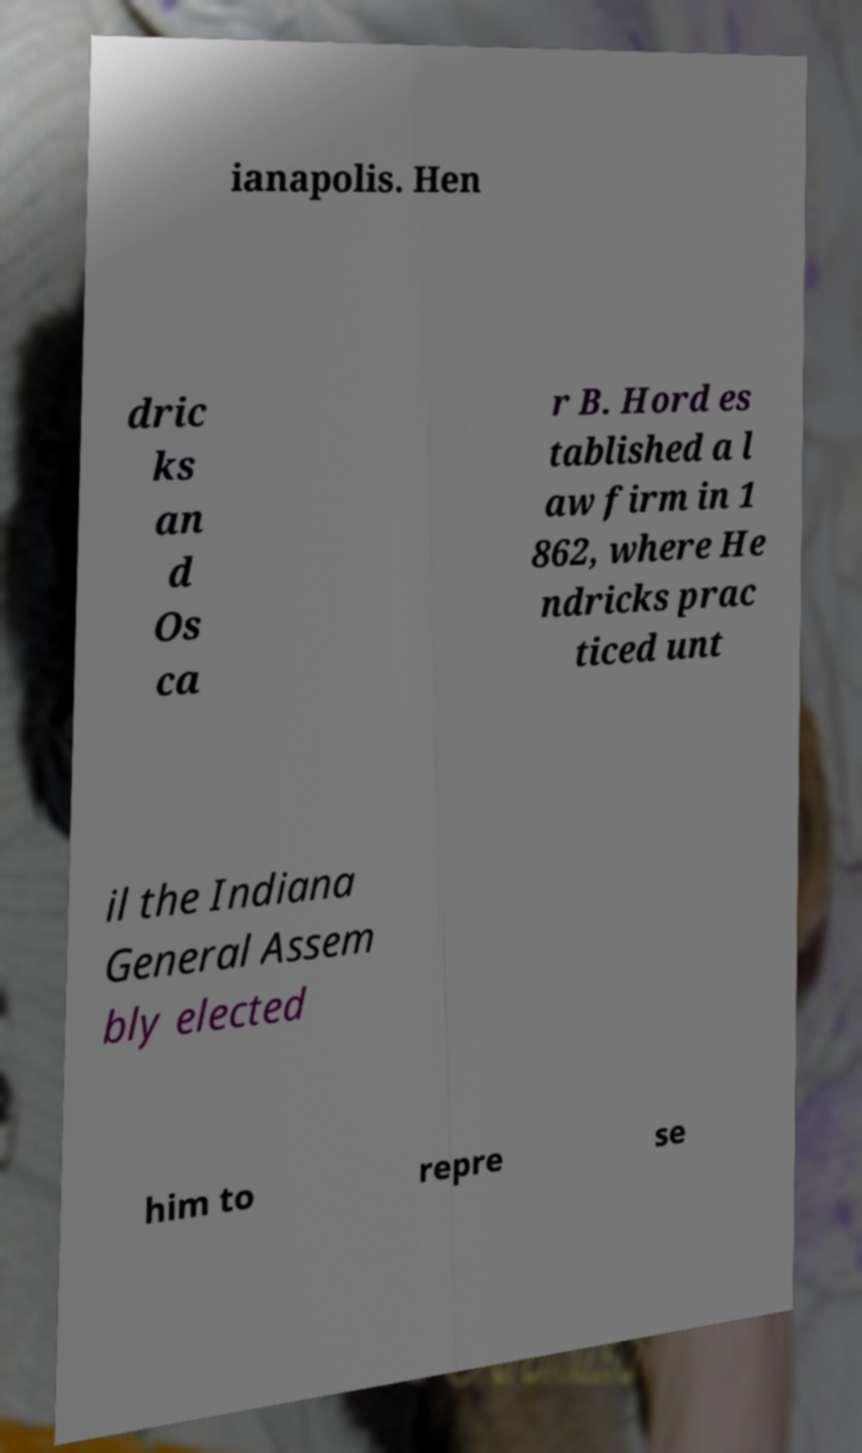For documentation purposes, I need the text within this image transcribed. Could you provide that? ianapolis. Hen dric ks an d Os ca r B. Hord es tablished a l aw firm in 1 862, where He ndricks prac ticed unt il the Indiana General Assem bly elected him to repre se 